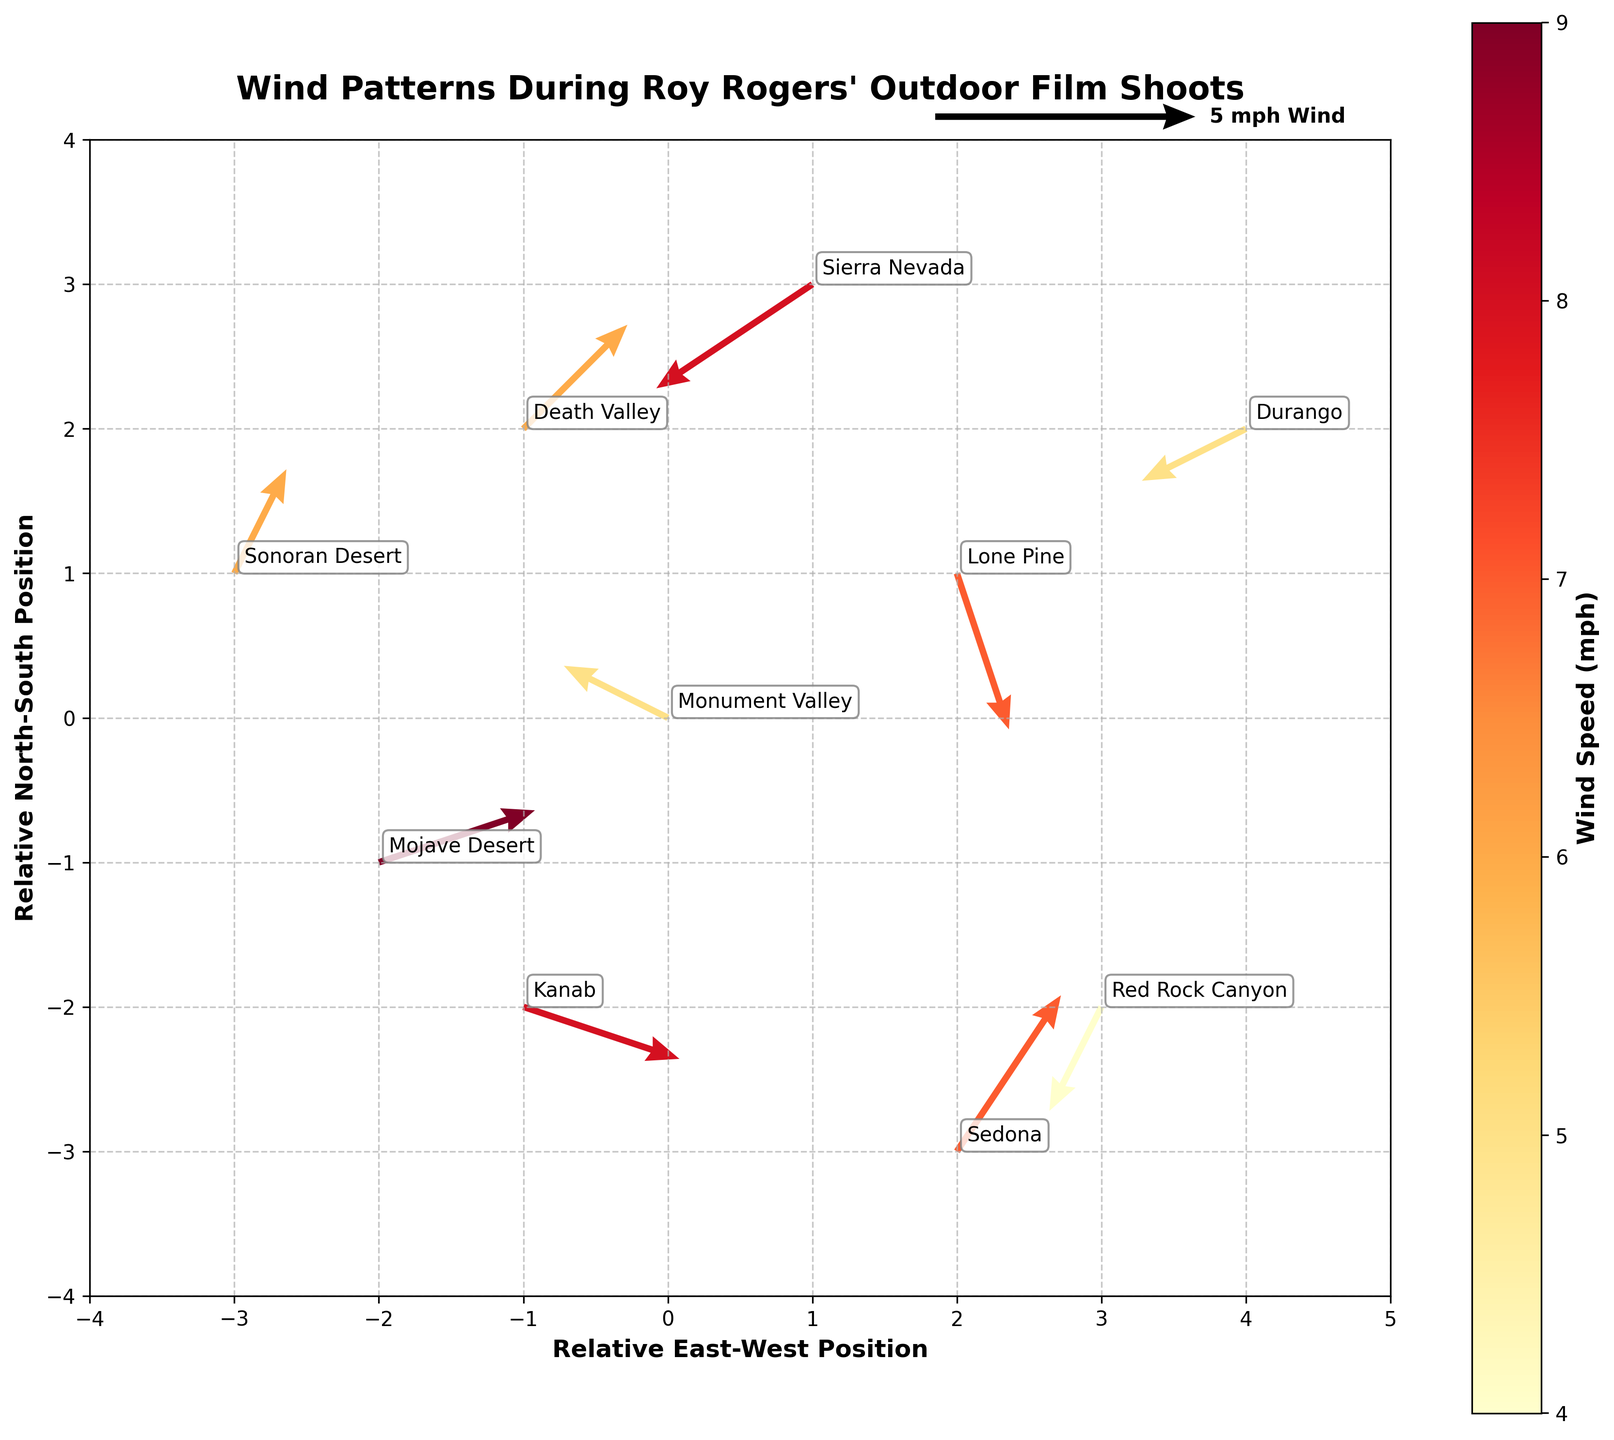What's the title of the quiver plot? The title is located at the top of the figure. It summarises the main topic of the plot.
Answer: Wind Patterns During Roy Rogers' Outdoor Film Shoots How many film shoot locations are shown in the plot? To determine the number of locations, count the unique annotated points on the plot representing different locations.
Answer: 10 What direction is the wind blowing in Monument Valley? Find Monument Valley by its annotation, then look at the direction of the arrow originating from that point. The arrow's tail represents the origin, and the head represents the direction the wind is blowing towards.
Answer: Southwest Which location has the highest wind speed? Look at the colorbar and the color intensity of the arrows. The location with the highest wind speed will have the darkest color representing the highest value on the color scale.
Answer: Mojave Desert Which locations have wind blowing towards the north? Identify the arrows pointing in the upward direction (towards the top of the plot) and note their corresponding locations.
Answer: Death Valley, Sonoran Desert Compare the wind speeds of Sierra Nevada and Lone Pine. Which location has a higher wind speed? Observe the color of the arrows at both locations, according to the colorbar. The location with the darker color will have a higher wind speed.
Answer: Sierra Nevada What is the predominant wind direction at Sedona? Find the annotation for Sedona, then observe the direction of the arrow at that point. The direction it points to indicates the predominant wind direction.
Answer: Northeast Calculate the average wind speed of the given locations. Add the wind speeds of all locations and divide by the number of locations. (5 + 7 + 8 + 6 + 9 + 4 + 7 + 5 + 6 + 8) / 10 = 65 / 10
Answer: 6.5 mph Which location has the wind blowing from the east to the west direction? Look for arrows that originate from the right and point to the left. Note the corresponding location.
Answer: Kanab How does the wind pattern in Red Rock Canyon compare to Durango? Compare the direction and length of the arrows originating from these two locations. Red Rock Canyon has a shorter arrow indicating lower speed and a different direction from Durango.
Answer: Wind in Red Rock Canyon is slower and blows towards the south, while in Durango, it blows towards the southwest 